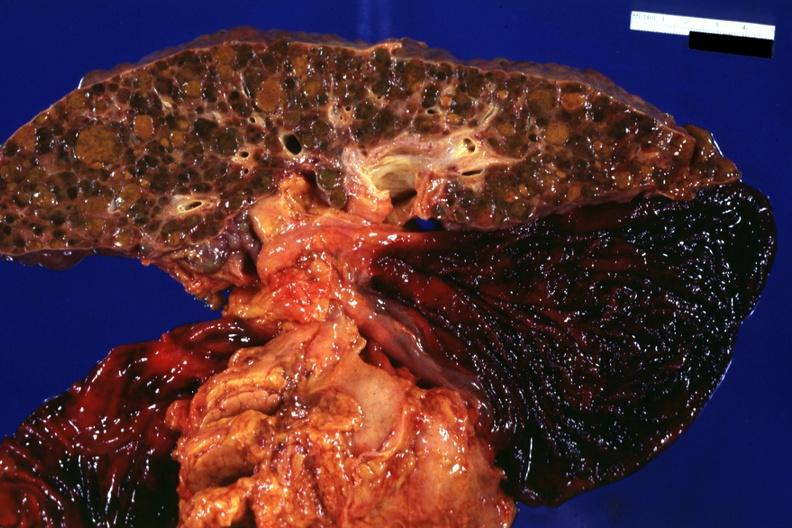what is present?
Answer the question using a single word or phrase. Liver 